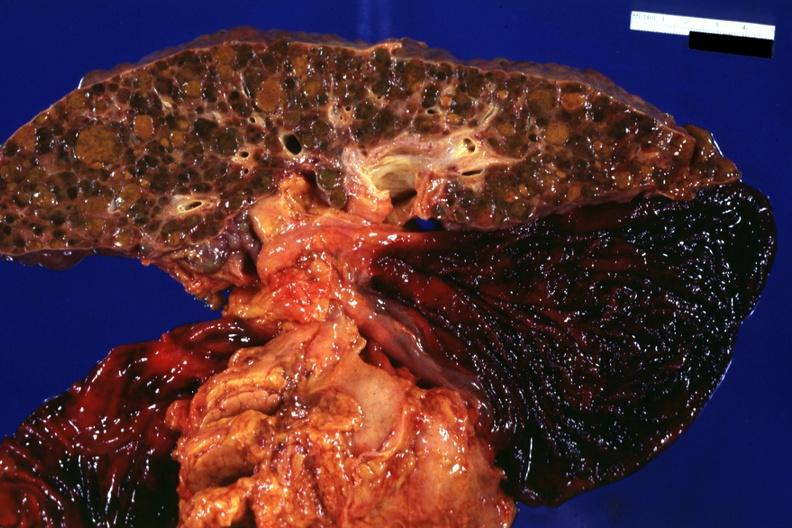what is present?
Answer the question using a single word or phrase. Liver 